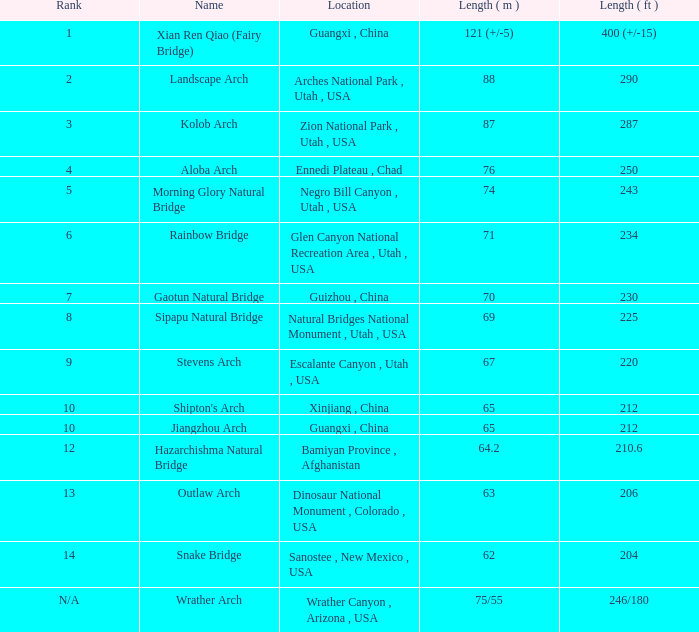What is the rank of the arch with a length in meters of 75/55? N/A. 